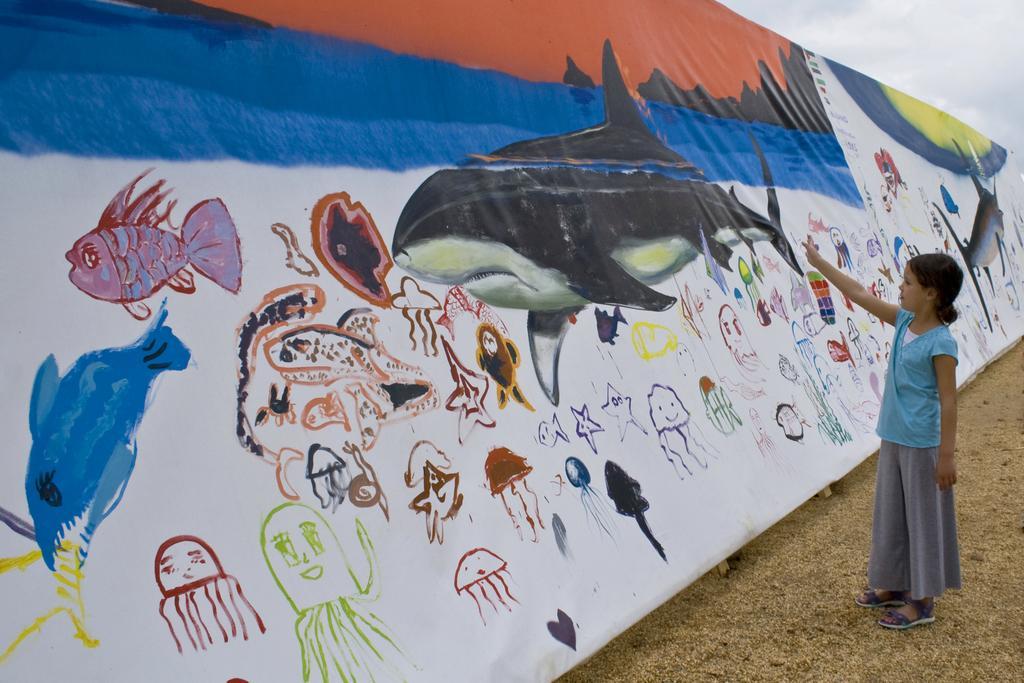Please provide a concise description of this image. To the right side of the image there is a girl. To the left side of the image there is a banner with paintings. At the bottom of the image there is sand. At the top of the image there is sky. 